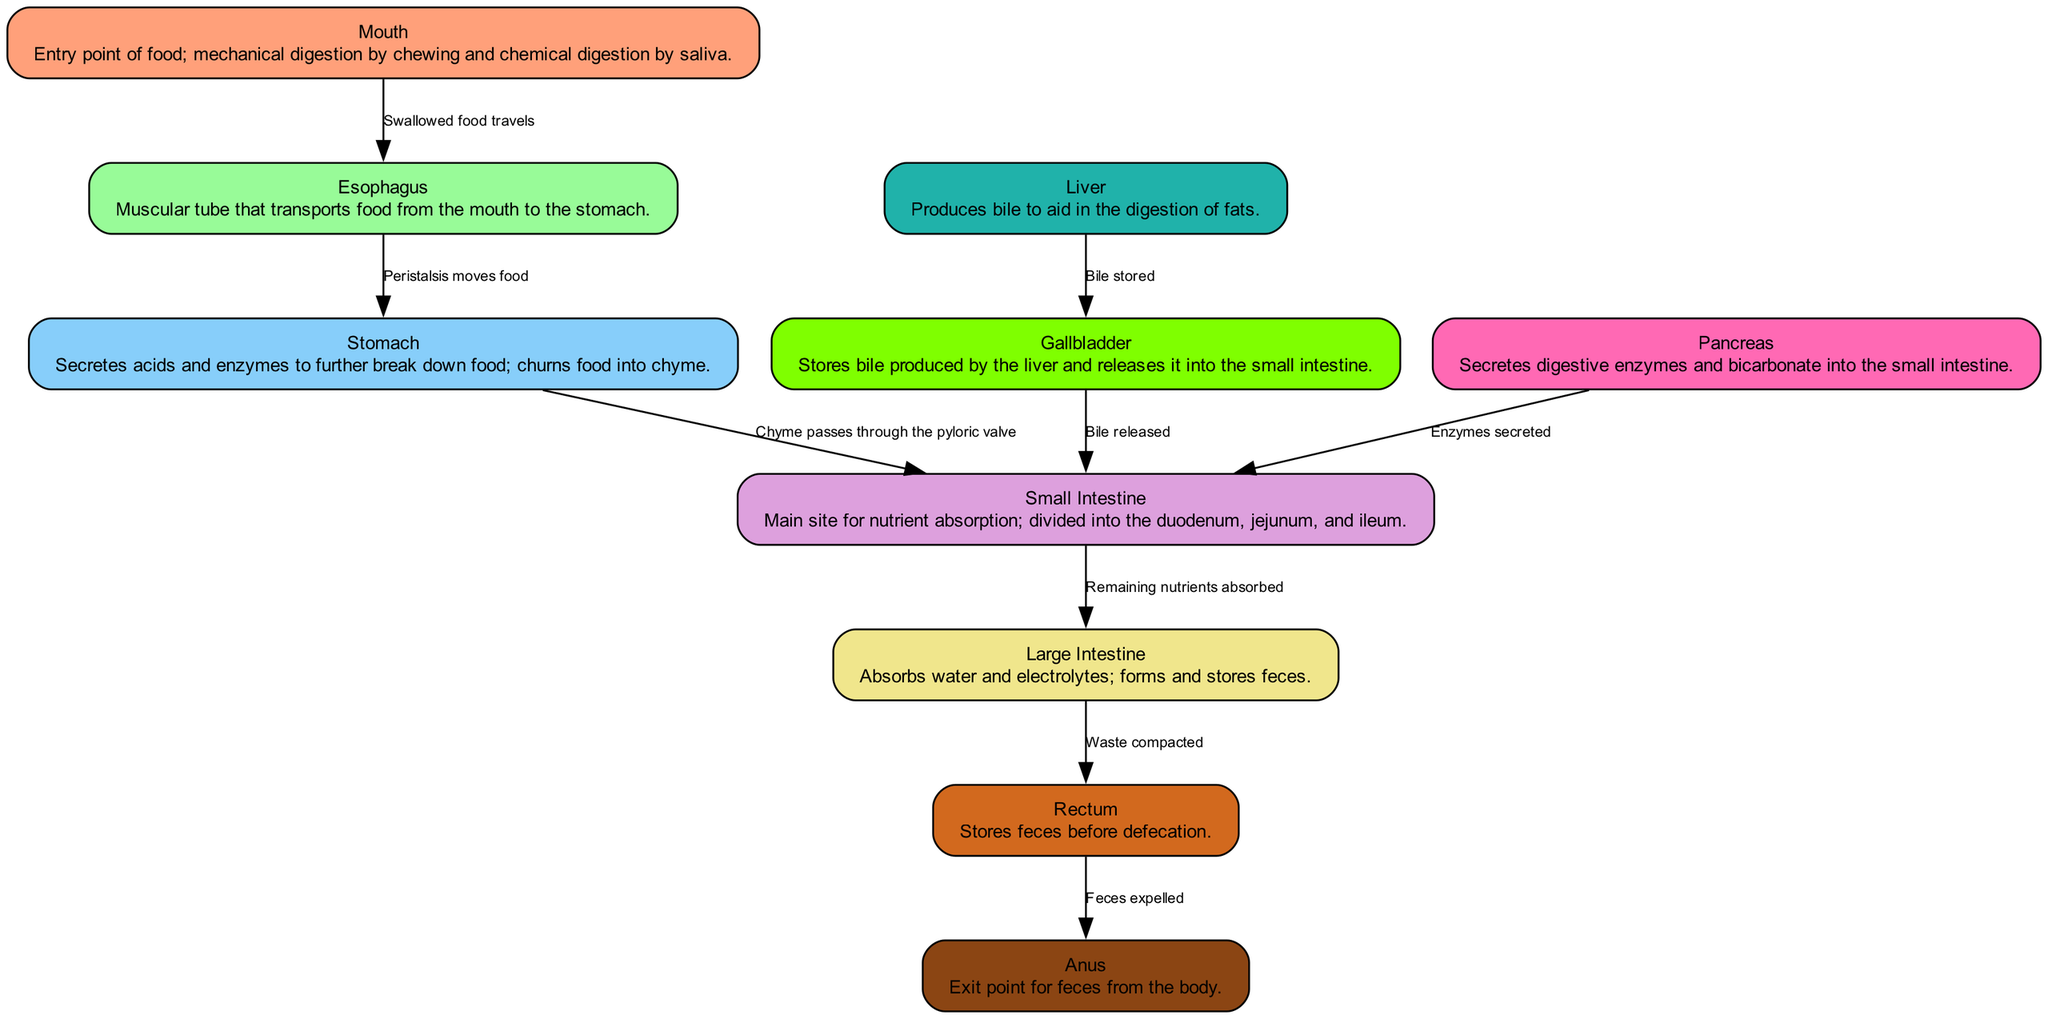what is the starting point of the digestive system? The diagram indicates that the mouth is the entry point of food, initiating the digestive process through mechanical and chemical digestion.
Answer: Mouth what transports food from the mouth to the stomach? According to the diagram, the esophagus is the muscular tube responsible for transporting food after it has been swallowed.
Answer: Esophagus which organ is primarily responsible for nutrient absorption? The small intestine is highlighted in the diagram as the main site where nutrient absorption occurs.
Answer: Small Intestine what connects the large intestine to the rectum? The diagram illustrates that the rectum stores feces formed from the waste compacted in the large intestine before elimination from the body.
Answer: Rectum how many accessory organs are shown in the diagram? By counting the nodes representing the liver, gallbladder, and pancreas, we see that there are three accessory organs depicted.
Answer: Three what role does the pancreas play in digestion? The diagram explains that the pancreas secretes digestive enzymes and bicarbonate into the small intestine, aiding in the digestive process.
Answer: Digestive enzymes what happens to waste after it is compacted in the large intestine? The diagram shows that the waste, once compacted in the large intestine, is transferred to the rectum for storage before being expelled.
Answer: Stored in the rectum which organ produces bile for fat digestion? According to the diagram, the liver is responsible for producing bile that aids in the digestion of fats.
Answer: Liver what is the final exit point for feces in the digestive system? The anus is indicated in the diagram as the exit point for feces to leave the body once the rectum is full.
Answer: Anus 